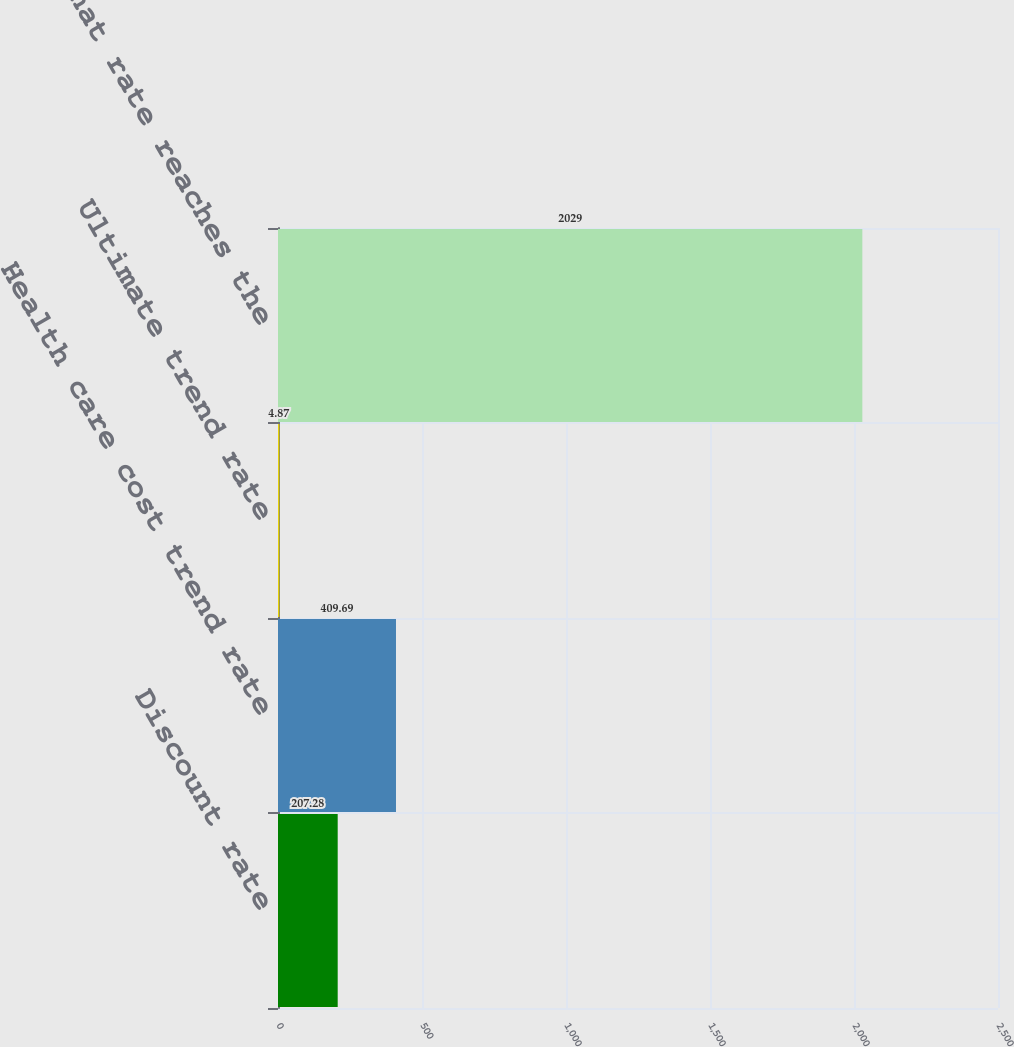Convert chart to OTSL. <chart><loc_0><loc_0><loc_500><loc_500><bar_chart><fcel>Discount rate<fcel>Health care cost trend rate<fcel>Ultimate trend rate<fcel>Year that rate reaches the<nl><fcel>207.28<fcel>409.69<fcel>4.87<fcel>2029<nl></chart> 